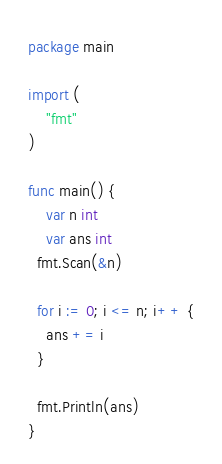<code> <loc_0><loc_0><loc_500><loc_500><_Go_>package main

import (
	"fmt"
)

func main() {
	var n int
  	var ans int
  fmt.Scan(&n)
  
  for i := 0; i <= n; i++ {
  	ans += i
  }
  
  fmt.Println(ans)
}
</code> 